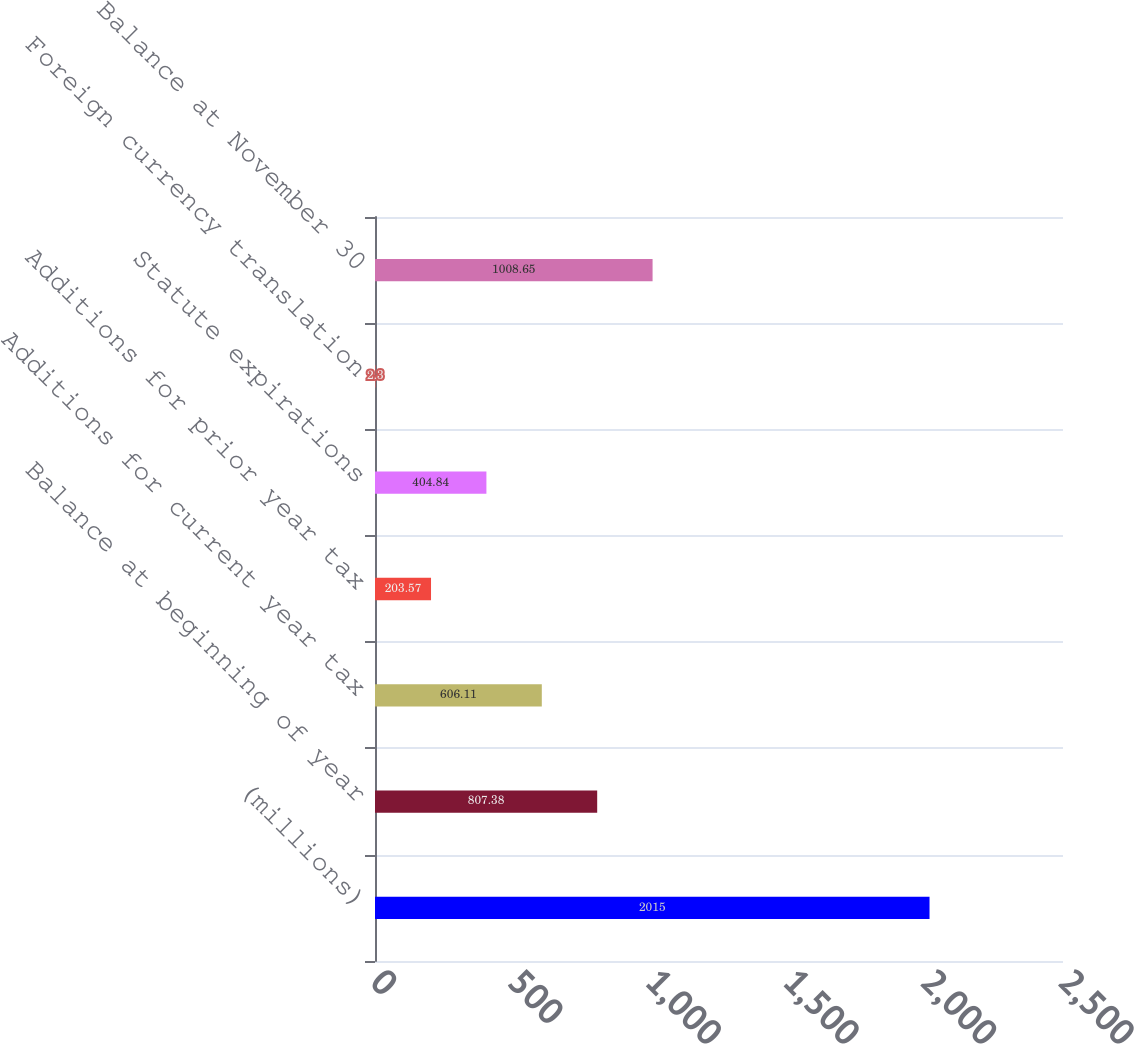<chart> <loc_0><loc_0><loc_500><loc_500><bar_chart><fcel>(millions)<fcel>Balance at beginning of year<fcel>Additions for current year tax<fcel>Additions for prior year tax<fcel>Statute expirations<fcel>Foreign currency translation<fcel>Balance at November 30<nl><fcel>2015<fcel>807.38<fcel>606.11<fcel>203.57<fcel>404.84<fcel>2.3<fcel>1008.65<nl></chart> 